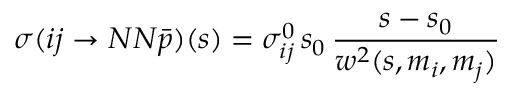Convert formula to latex. <formula><loc_0><loc_0><loc_500><loc_500>\sigma ( i j \rightarrow N N \bar { p } ) ( s ) = \sigma _ { i j } ^ { 0 } \, s _ { 0 } \, \frac { s - s _ { 0 } } { w ^ { 2 } ( s , m _ { i } , m _ { j } ) }</formula> 